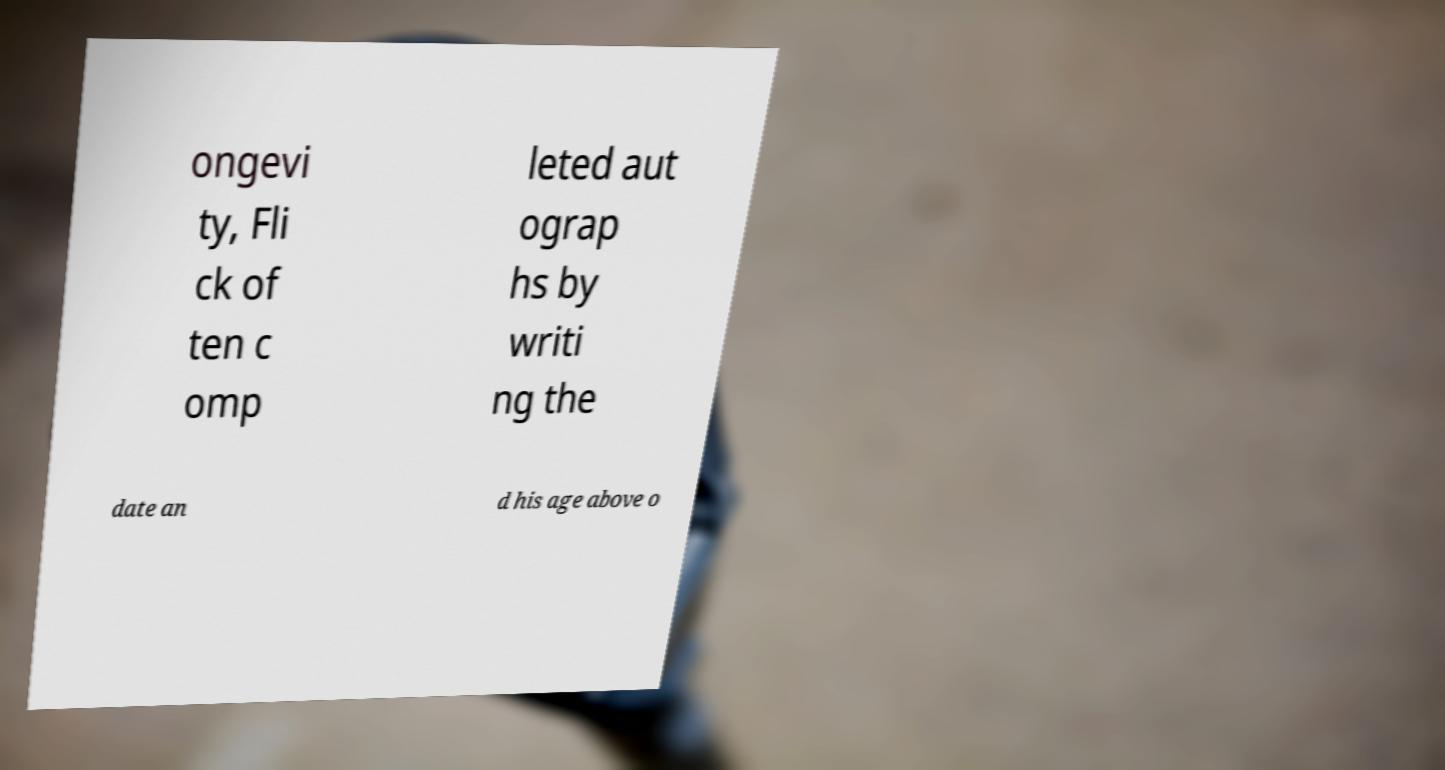For documentation purposes, I need the text within this image transcribed. Could you provide that? ongevi ty, Fli ck of ten c omp leted aut ograp hs by writi ng the date an d his age above o 